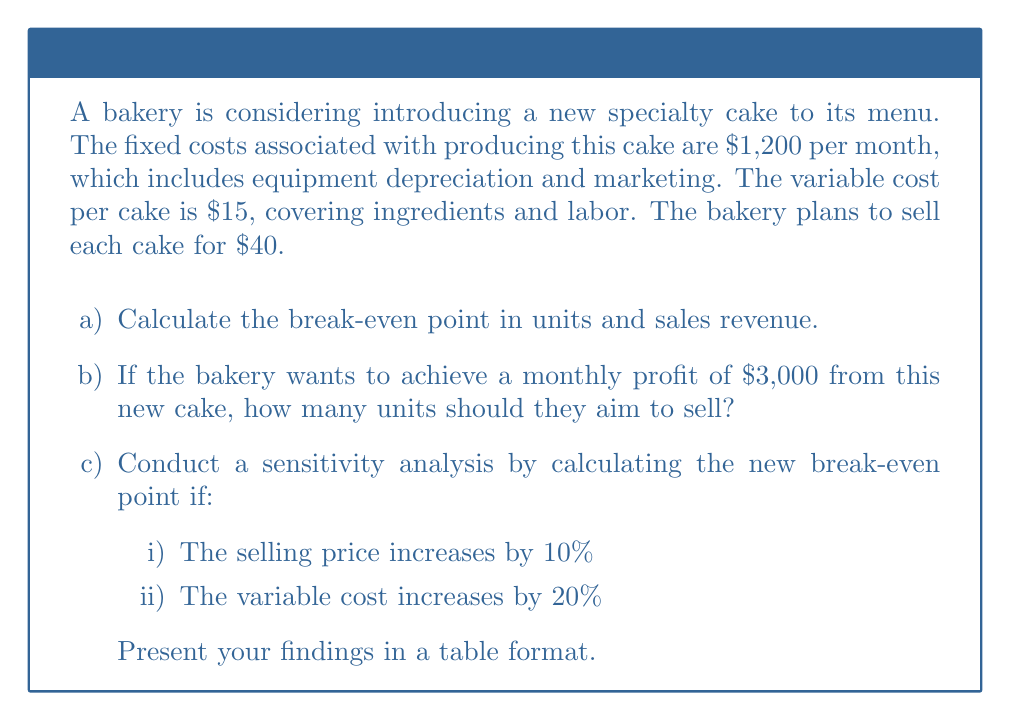Solve this math problem. Let's approach this problem step-by-step:

1) Break-even analysis:
   Let $x$ be the number of units sold.
   Fixed costs (FC) = $1,200
   Variable cost (VC) per unit = $15
   Selling price (P) per unit = $40

   At break-even point: Total Revenue = Total Costs
   $$40x = 1200 + 15x$$
   $$25x = 1200$$
   $$x = 48$$

   Break-even point in units = 48 cakes
   Break-even point in sales revenue = $40 * 48 = $1,920

2) To achieve a monthly profit of $3,000:
   $$40x = 1200 + 15x + 3000$$
   $$25x = 4200$$
   $$x = 168$$

3) Sensitivity analysis:
   i) If selling price increases by 10%:
      New selling price = $40 * 1.1 = $44
      $$44x = 1200 + 15x$$
      $$29x = 1200$$
      $$x ≈ 41.38$$

   ii) If variable cost increases by 20%:
       New variable cost = $15 * 1.2 = $18
       $$40x = 1200 + 18x$$
       $$22x = 1200$$
       $$x ≈ 54.55$$

Results table:

| Scenario                      | Break-even Point (units) |
|-------------------------------|--------------------------|
| Original                      | 48.00                    |
| 10% increase in selling price | 41.38                    |
| 20% increase in variable cost | 54.55                    |
Answer: a) 48 units, $1,920 revenue
b) 168 units
c) i) 41.38 units, ii) 54.55 units 